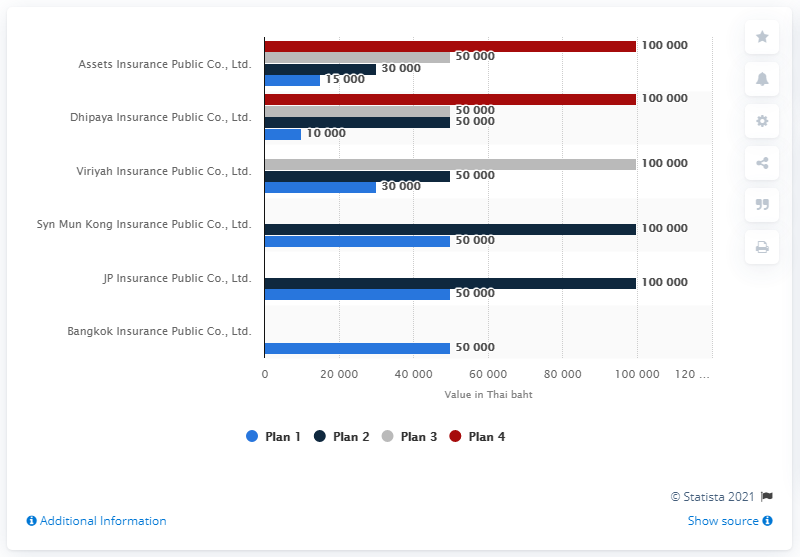Identify some key points in this picture. The color bar representing plan 4 in the chart is red. The average of plan 1, the blue bar, is 34166. 